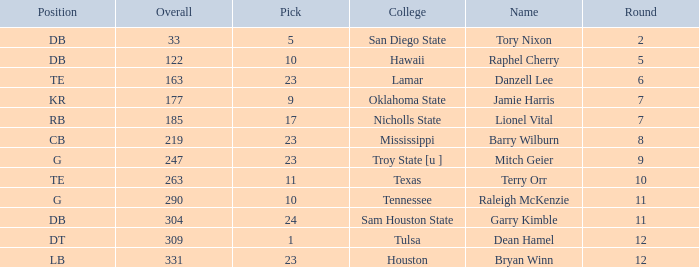Which Round is the highest one that has a Pick smaller than 10, and a Name of tory nixon? 2.0. 